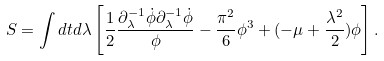Convert formula to latex. <formula><loc_0><loc_0><loc_500><loc_500>S = \int d t d \lambda \left [ \frac { 1 } { 2 } \frac { \partial ^ { - 1 } _ { \lambda } \dot { \phi } \partial ^ { - 1 } _ { \lambda } \dot { \phi } } { \phi } - \frac { \pi ^ { 2 } } { 6 } \phi ^ { 3 } + ( - \mu + \frac { \lambda ^ { 2 } } { 2 } ) \phi \right ] .</formula> 